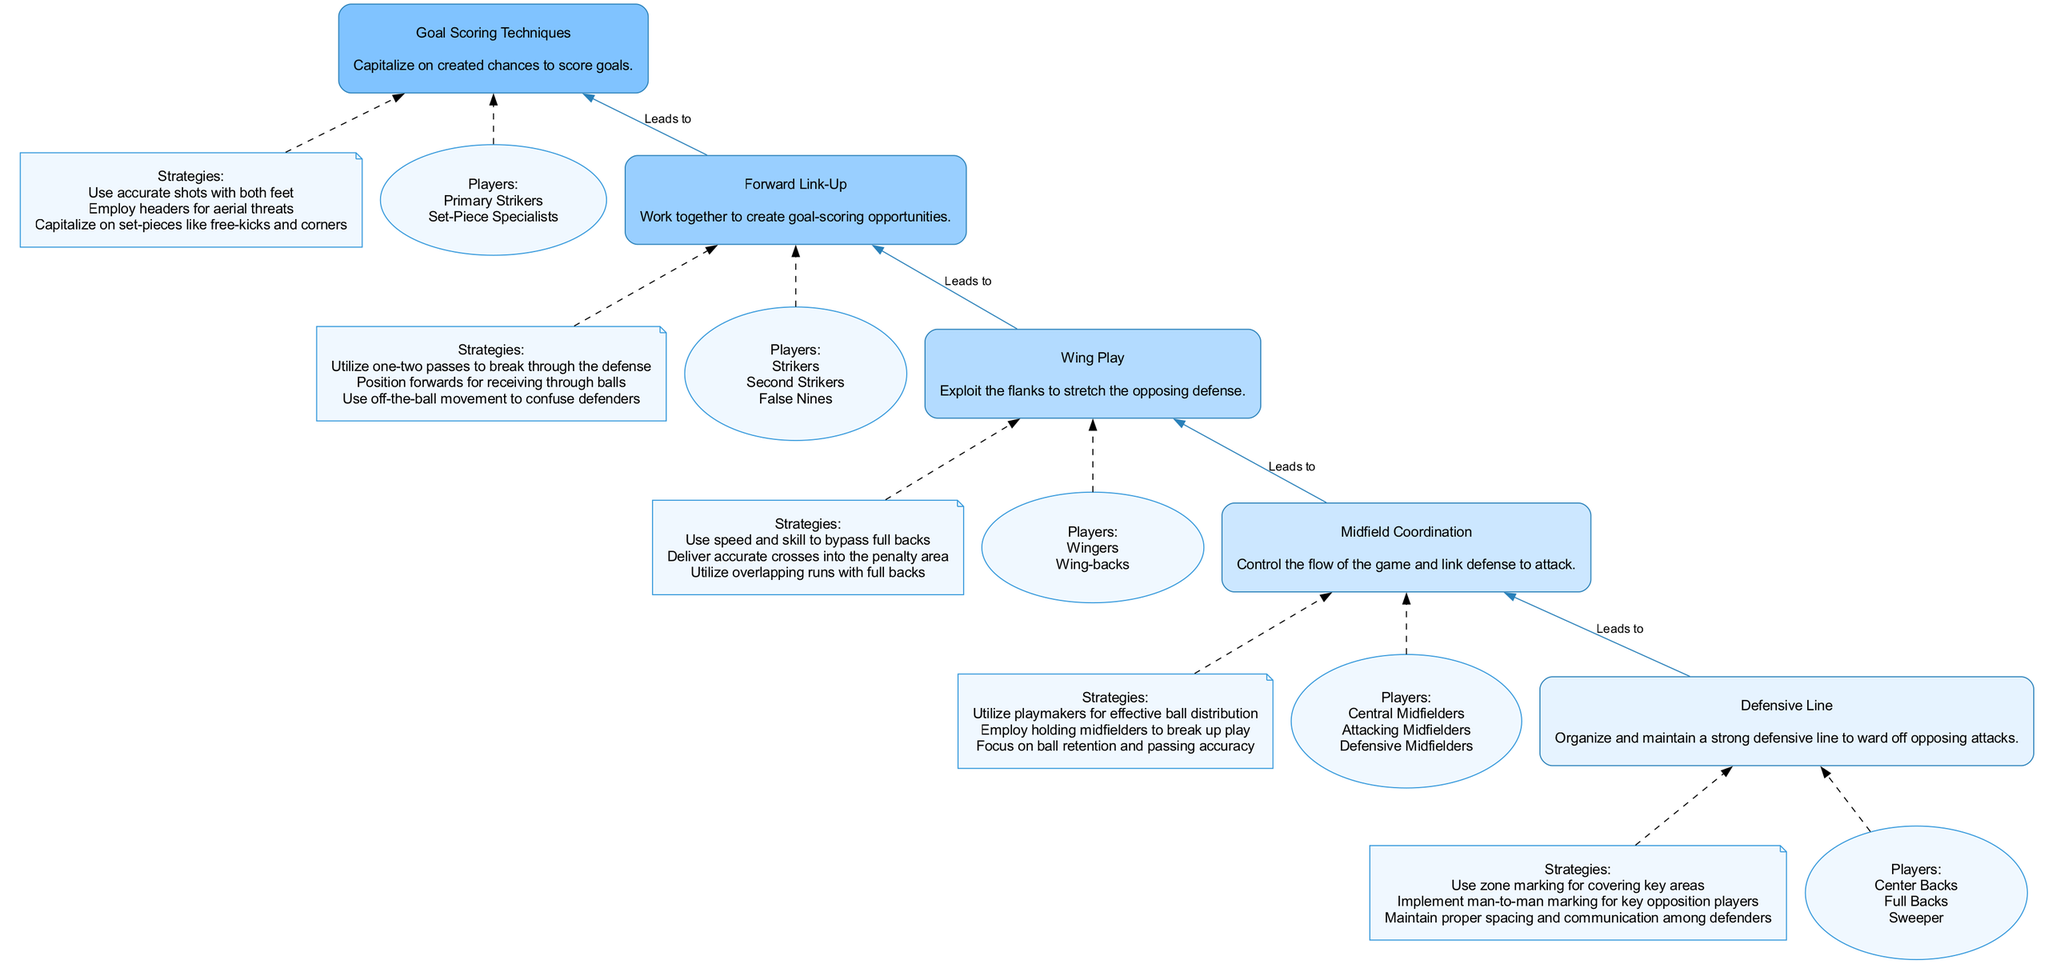What is the top node in the diagram? The top node of the diagram represents the final goal of the flow chart, which is "Goal Scoring Techniques." Since the flow chart is organized from bottom to top, the last element is placed at the top.
Answer: Goal Scoring Techniques How many elements are there in the flow chart? The flow chart consists of five elements that are sequentially organized from the defensive strategy at the bottom to goal-scoring techniques at the top.
Answer: 5 Which node leads directly to "Midfield Coordination"? The node "Defensive Line" leads directly to "Midfield Coordination" as indicated by the edge connecting these two elements in the diagram.
Answer: Defensive Line What players are associated with "Wing Play"? The players associated with "Wing Play" are indicated in the details of that node, specifically mentioning "Wingers" and "Wing-backs."
Answer: Wingers, Wing-backs What strategies are listed under "Forward Link-Up"? The strategies under "Forward Link-Up" include three specific tactics focused on collaborating to create scoring opportunities which are listed clearly in the details of the node.
Answer: Utilize one-two passes to break through the defense, Position forwards for receiving through balls, Use off-the-ball movement to confuse defenders What flows into "Goal Scoring Techniques"? The directly preceding node, "Forward Link-Up," flows into "Goal Scoring Techniques," indicating that the strategies for linking forwards lead to the final goal-scoring strategies in the chart.
Answer: Forward Link-Up How are the nodes connected in terms of strategy progression? Each node is systematically connected in a logical flow that represents the progression of strategies leading up to scoring goals, illustrating that each part gains importance as the diagram moves upwards from defense to attack.
Answer: By strategic progression from Defensive Line to Goal Scoring Techniques What type of players is mentioned in the "Defensive Line"? The players specified in the "Defensive Line" node include "Center Backs," "Full Backs," and "Sweeper" as mentioned explicitly in the description and players section of that node.
Answer: Center Backs, Full Backs, Sweeper 